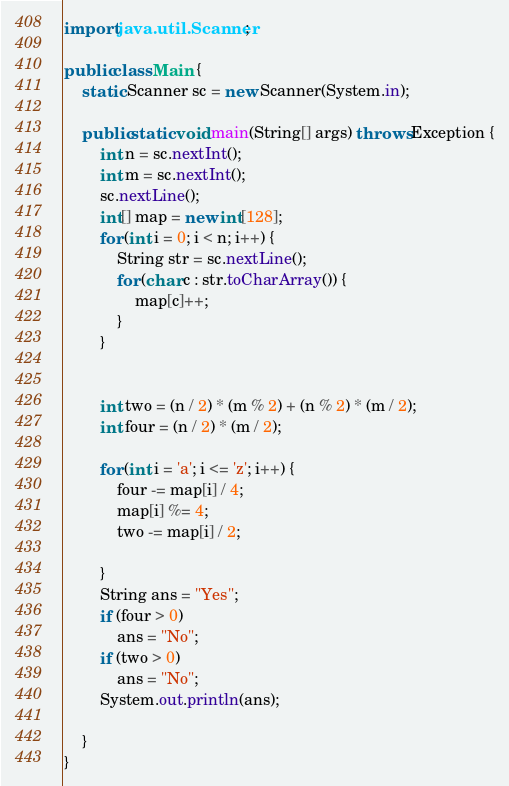Convert code to text. <code><loc_0><loc_0><loc_500><loc_500><_Java_>import java.util.Scanner;

public class Main {
	static Scanner sc = new Scanner(System.in);

	public static void main(String[] args) throws Exception {
		int n = sc.nextInt();
		int m = sc.nextInt();
		sc.nextLine();
		int[] map = new int[128];
		for (int i = 0; i < n; i++) {
			String str = sc.nextLine();
			for (char c : str.toCharArray()) {
				map[c]++;
			}
		}


		int two = (n / 2) * (m % 2) + (n % 2) * (m / 2);
		int four = (n / 2) * (m / 2);

		for (int i = 'a'; i <= 'z'; i++) {
			four -= map[i] / 4;
			map[i] %= 4;
			two -= map[i] / 2;

		}
		String ans = "Yes";
		if (four > 0)
			ans = "No";
		if (two > 0)
			ans = "No";
		System.out.println(ans);

	}
}
</code> 